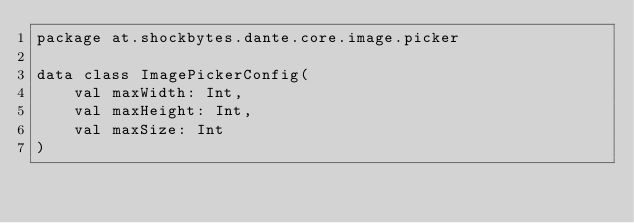<code> <loc_0><loc_0><loc_500><loc_500><_Kotlin_>package at.shockbytes.dante.core.image.picker

data class ImagePickerConfig(
    val maxWidth: Int,
    val maxHeight: Int,
    val maxSize: Int
)
</code> 